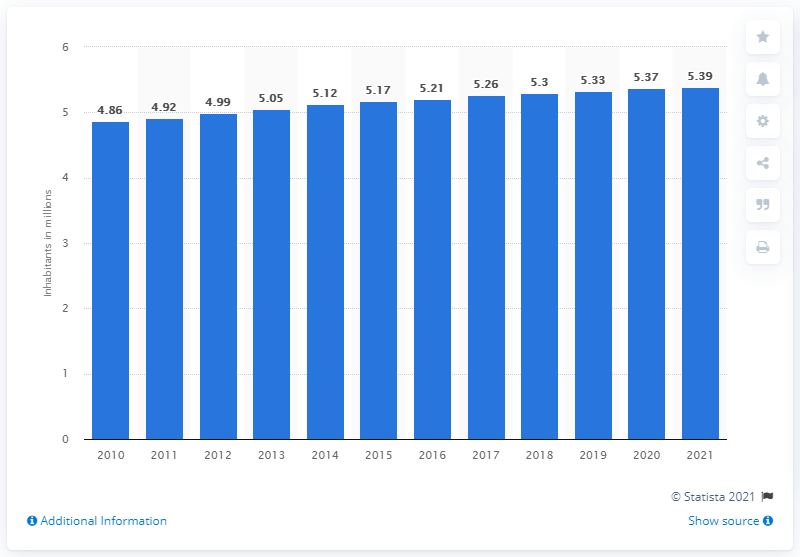Specify some key components in this picture. In 2011, the population of Norway was approximately 4.92 million. In 2021, the population of Norway was 5.39 million. 